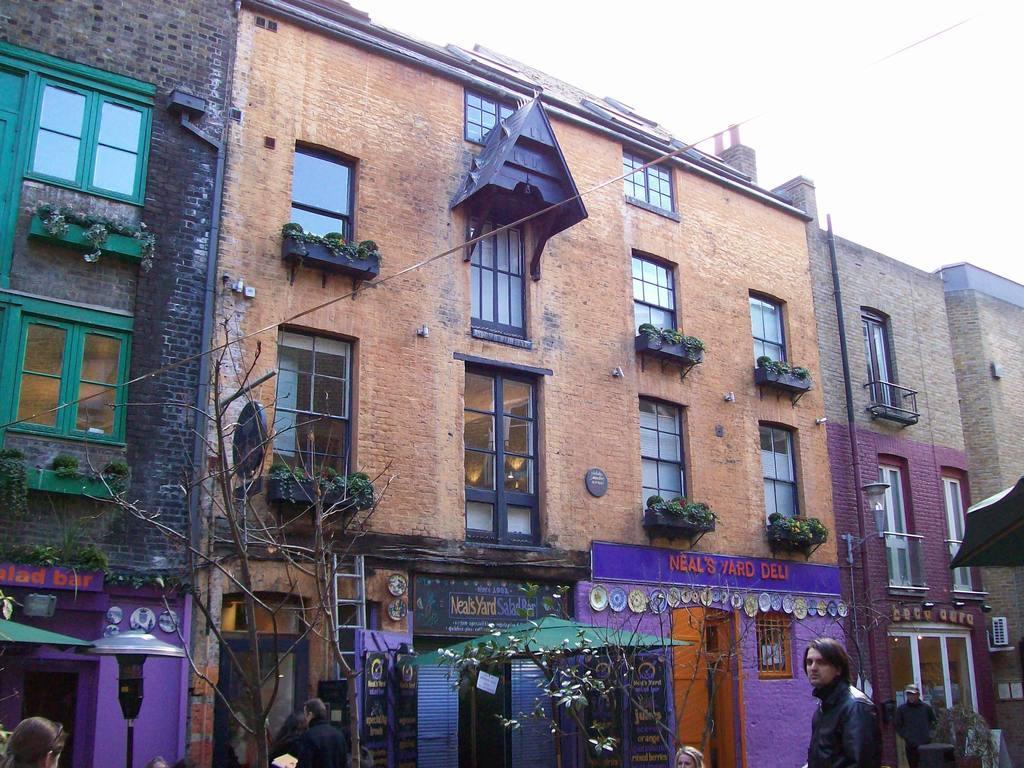In one or two sentences, can you explain what this image depicts? In this image, there are a few buildings. We can see some dried trees and plants. We can see some boards with text. There are a few people and tents. We can see some poles and a wire. We can see an object on the right. We can also see the sky. 